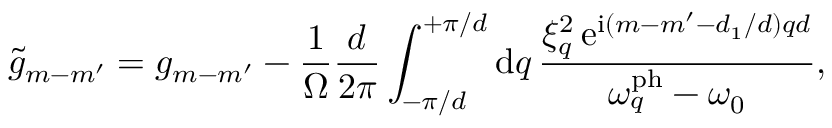Convert formula to latex. <formula><loc_0><loc_0><loc_500><loc_500>\tilde { g } _ { m - m ^ { \prime } } = g _ { m - m ^ { \prime } } - \frac { 1 } { \Omega } \frac { d } { 2 \pi } \int _ { - \pi / d } ^ { + \pi / d } d q \, \frac { \xi _ { q } ^ { 2 } \, e ^ { i ( m - m ^ { \prime } - d _ { 1 } / d ) q d } } { \omega _ { q } ^ { p h } - \omega _ { 0 } } ,</formula> 